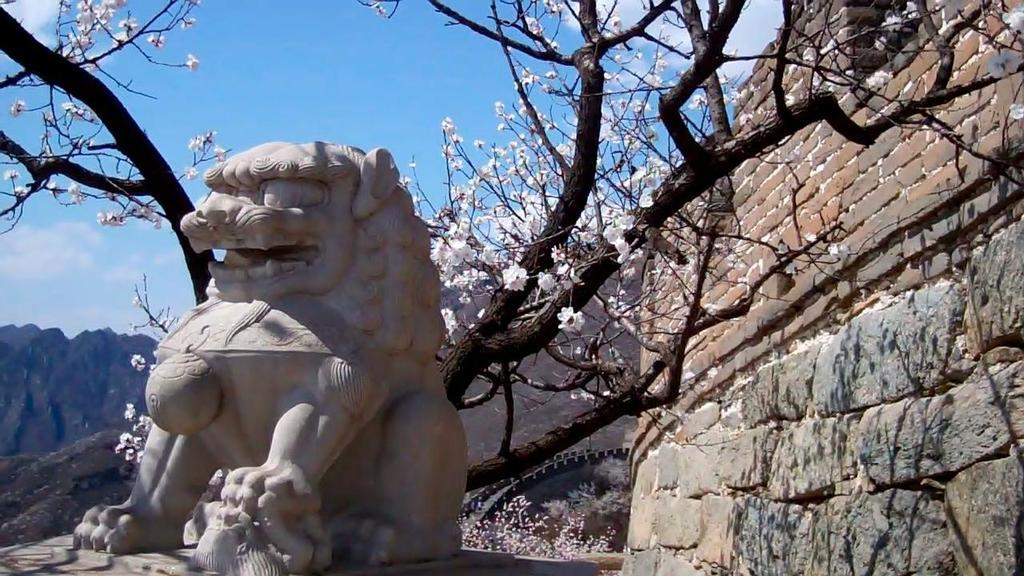What is the main subject in the center of the image? There is a statue in the center of the image. What can be seen in the background of the image? There is a tree with flowers and hills visible in the background of the image. What is located on the right side of the image? There is a wall on the right side of the image. Are there any horses stuck in quicksand in the image? There are no horses or quicksand present in the image. 